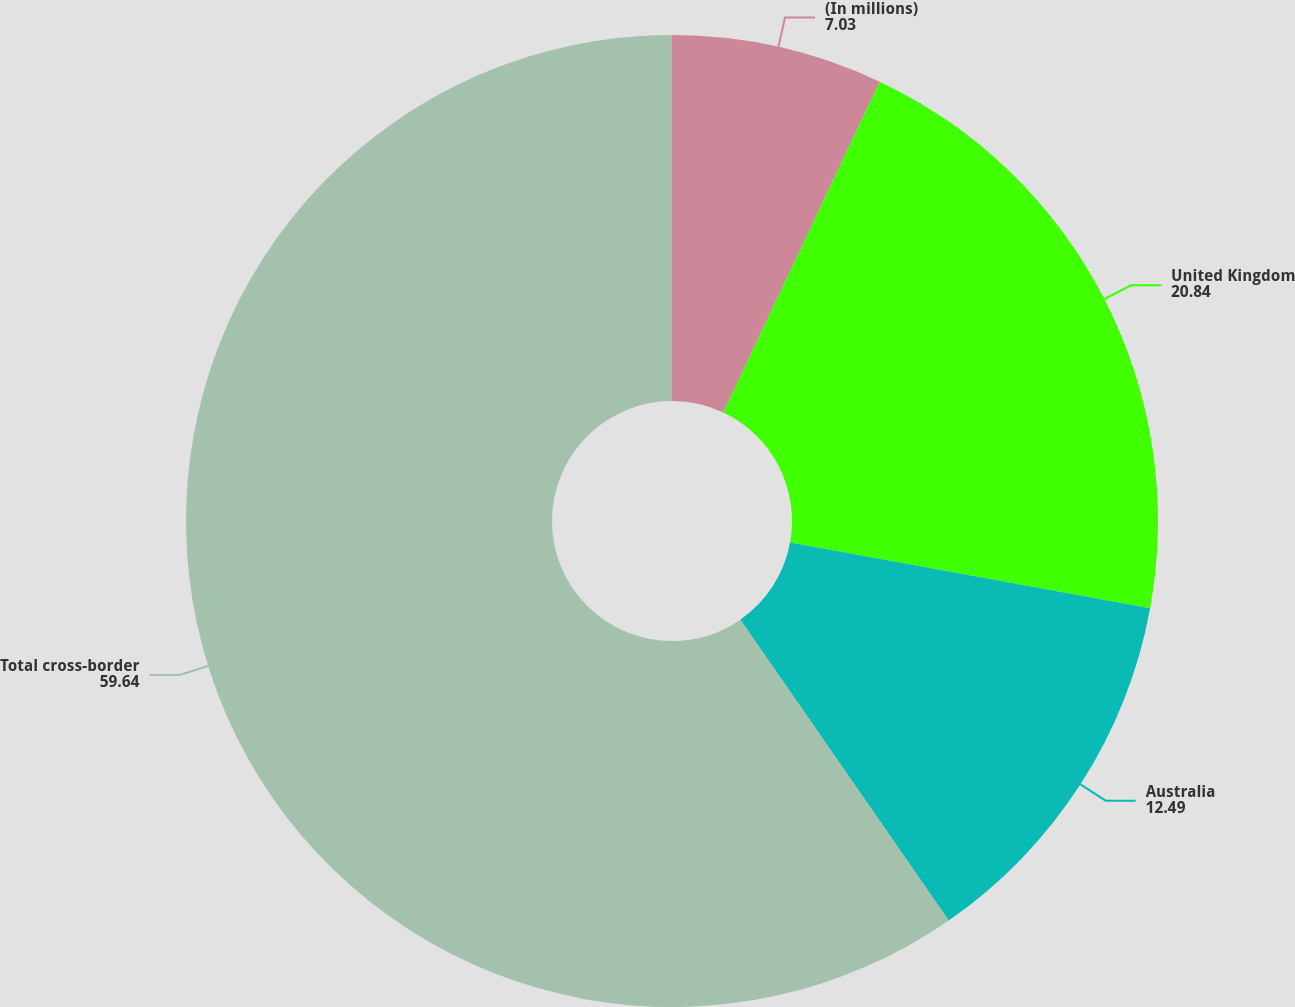<chart> <loc_0><loc_0><loc_500><loc_500><pie_chart><fcel>(In millions)<fcel>United Kingdom<fcel>Australia<fcel>Total cross-border<nl><fcel>7.03%<fcel>20.84%<fcel>12.49%<fcel>59.64%<nl></chart> 